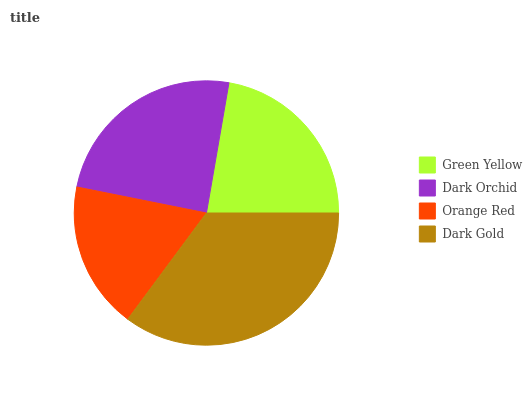Is Orange Red the minimum?
Answer yes or no. Yes. Is Dark Gold the maximum?
Answer yes or no. Yes. Is Dark Orchid the minimum?
Answer yes or no. No. Is Dark Orchid the maximum?
Answer yes or no. No. Is Dark Orchid greater than Green Yellow?
Answer yes or no. Yes. Is Green Yellow less than Dark Orchid?
Answer yes or no. Yes. Is Green Yellow greater than Dark Orchid?
Answer yes or no. No. Is Dark Orchid less than Green Yellow?
Answer yes or no. No. Is Dark Orchid the high median?
Answer yes or no. Yes. Is Green Yellow the low median?
Answer yes or no. Yes. Is Green Yellow the high median?
Answer yes or no. No. Is Dark Orchid the low median?
Answer yes or no. No. 